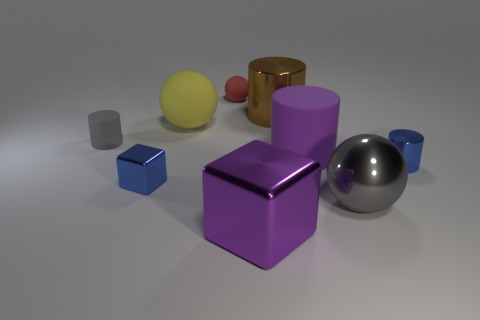Subtract all large rubber cylinders. How many cylinders are left? 3 Subtract all blue cylinders. How many cylinders are left? 3 Subtract 0 green blocks. How many objects are left? 9 Subtract all blocks. How many objects are left? 7 Subtract 3 cylinders. How many cylinders are left? 1 Subtract all cyan cylinders. Subtract all purple cubes. How many cylinders are left? 4 Subtract all purple balls. How many gray cylinders are left? 1 Subtract all rubber cylinders. Subtract all small blue cylinders. How many objects are left? 6 Add 3 tiny gray cylinders. How many tiny gray cylinders are left? 4 Add 1 large green balls. How many large green balls exist? 1 